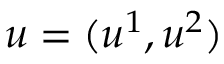Convert formula to latex. <formula><loc_0><loc_0><loc_500><loc_500>u = ( u ^ { 1 } , u ^ { 2 } )</formula> 